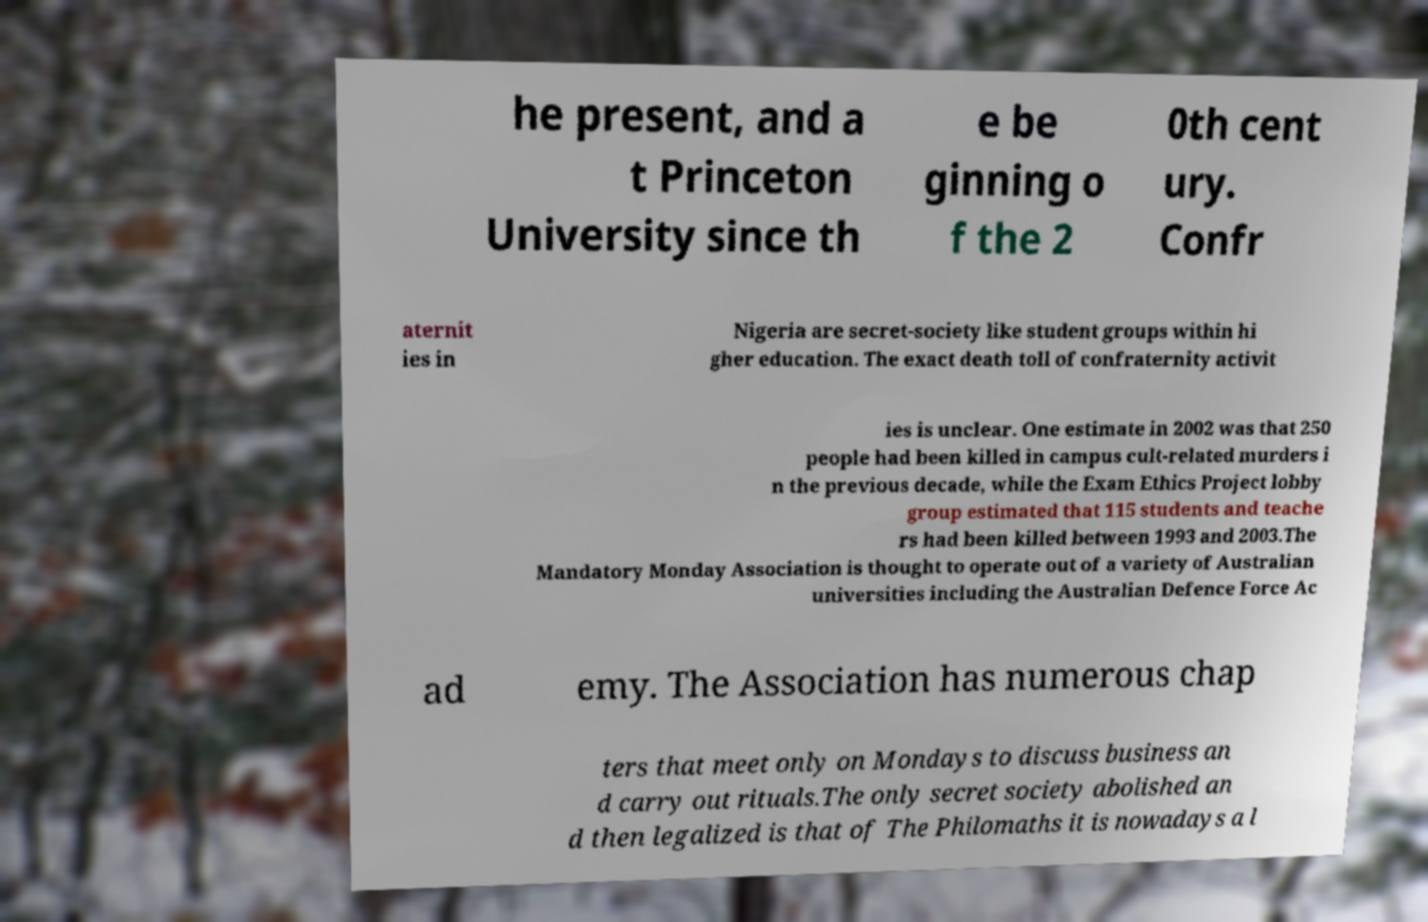I need the written content from this picture converted into text. Can you do that? he present, and a t Princeton University since th e be ginning o f the 2 0th cent ury. Confr aternit ies in Nigeria are secret-society like student groups within hi gher education. The exact death toll of confraternity activit ies is unclear. One estimate in 2002 was that 250 people had been killed in campus cult-related murders i n the previous decade, while the Exam Ethics Project lobby group estimated that 115 students and teache rs had been killed between 1993 and 2003.The Mandatory Monday Association is thought to operate out of a variety of Australian universities including the Australian Defence Force Ac ad emy. The Association has numerous chap ters that meet only on Mondays to discuss business an d carry out rituals.The only secret society abolished an d then legalized is that of The Philomaths it is nowadays a l 